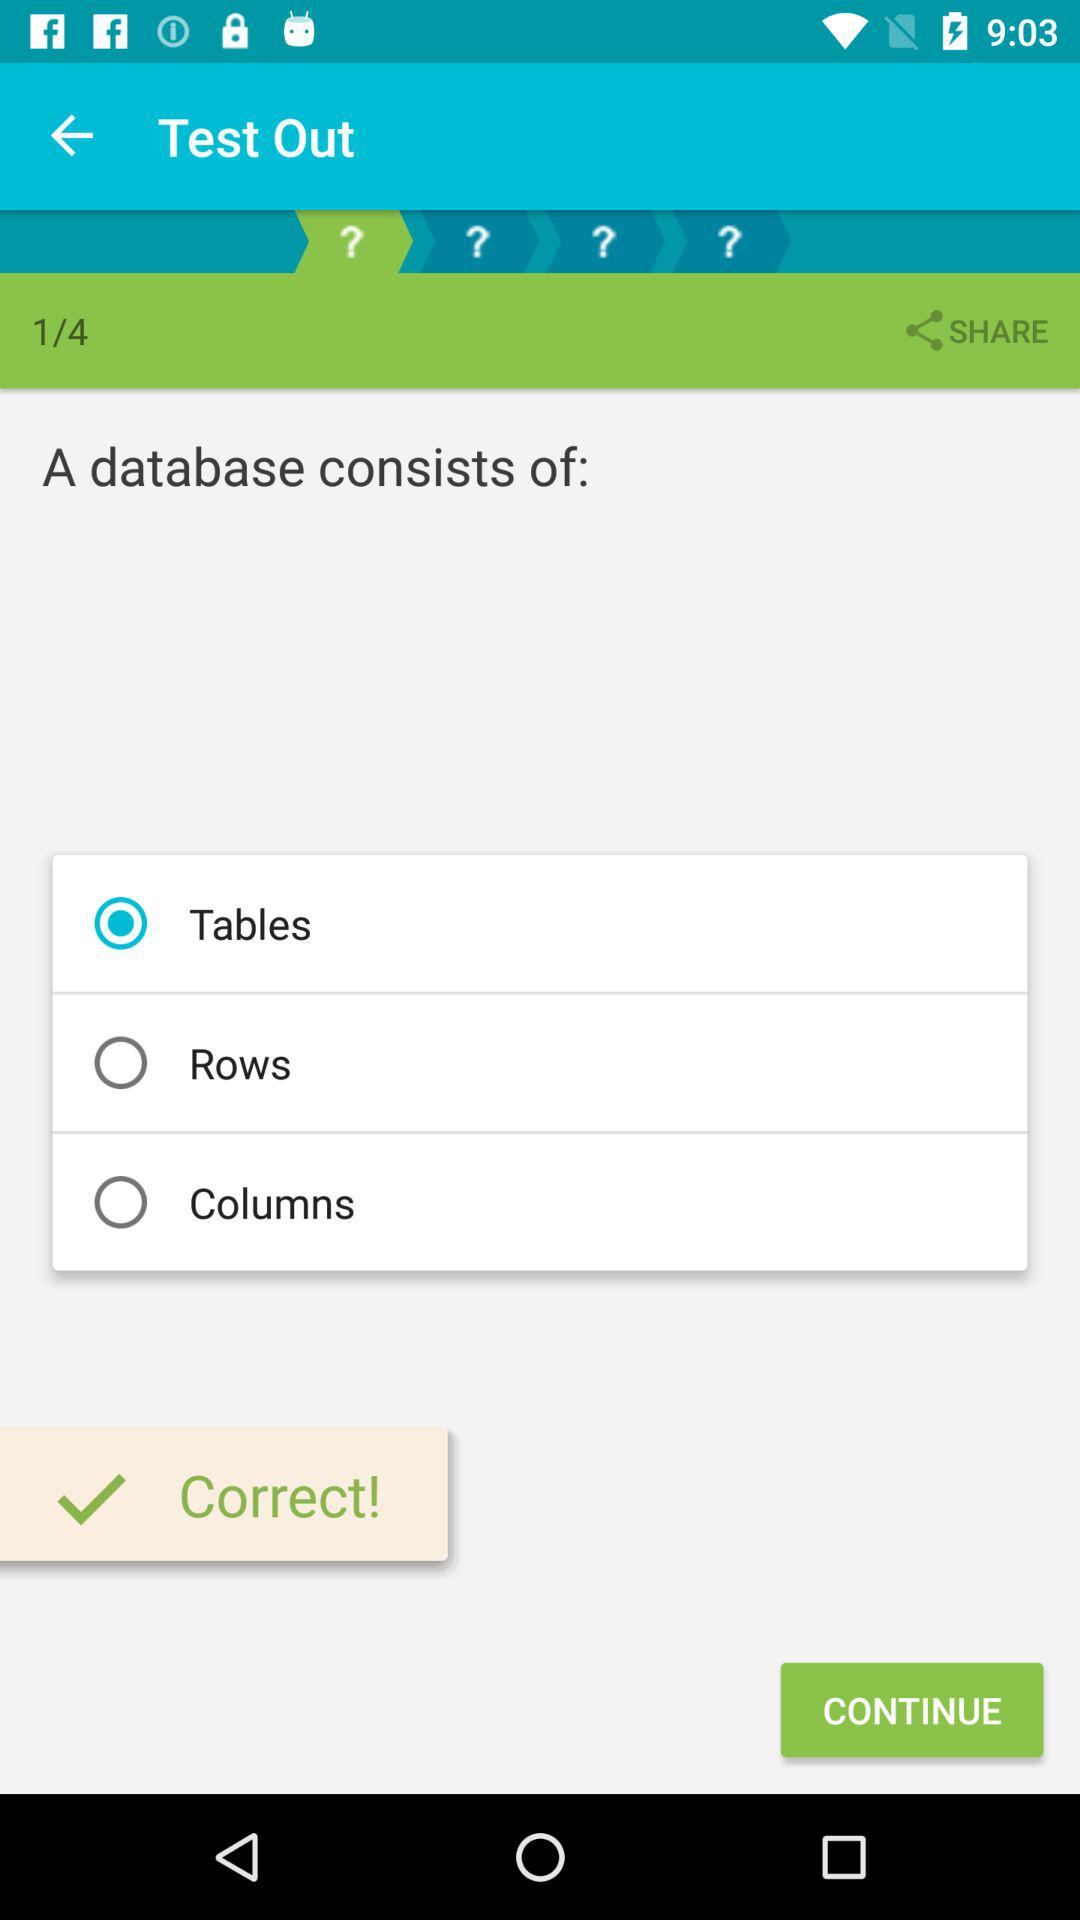What is the total number of questions? The total number of questions is 4. 